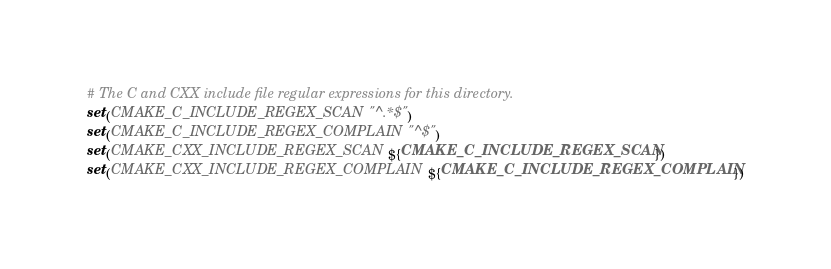<code> <loc_0><loc_0><loc_500><loc_500><_CMake_>

# The C and CXX include file regular expressions for this directory.
set(CMAKE_C_INCLUDE_REGEX_SCAN "^.*$")
set(CMAKE_C_INCLUDE_REGEX_COMPLAIN "^$")
set(CMAKE_CXX_INCLUDE_REGEX_SCAN ${CMAKE_C_INCLUDE_REGEX_SCAN})
set(CMAKE_CXX_INCLUDE_REGEX_COMPLAIN ${CMAKE_C_INCLUDE_REGEX_COMPLAIN})
</code> 